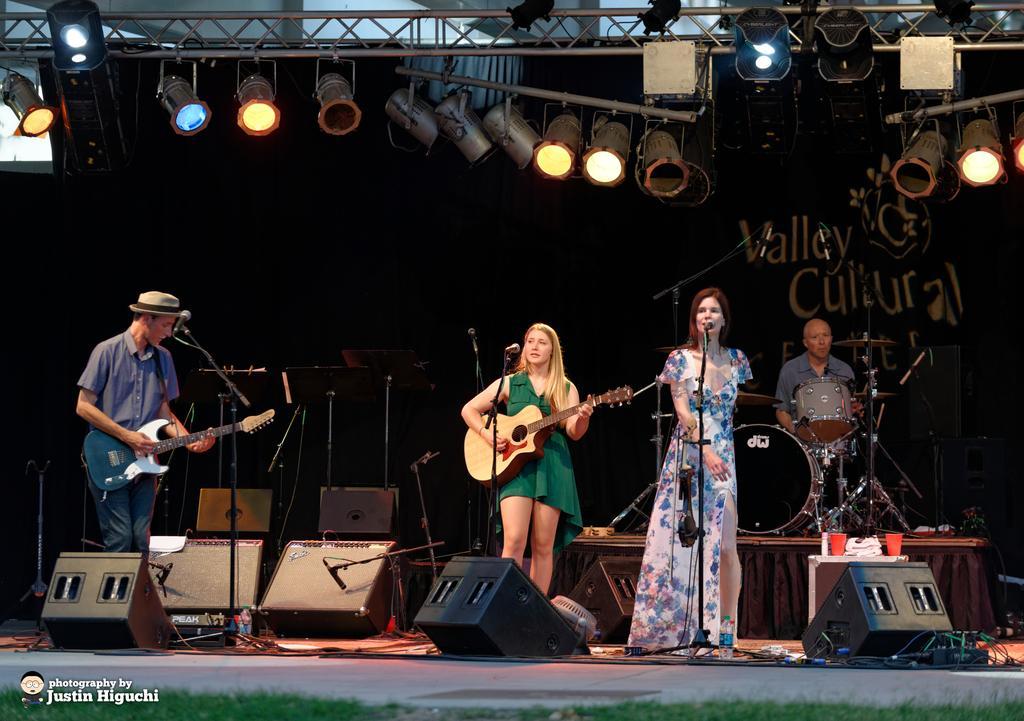Describe this image in one or two sentences. In this image we can see this woman is standing and singing. We can see this persons are holding a guitar and playing. In the background we can see this person is sitting and playing electronic drums. These are the show lights. 